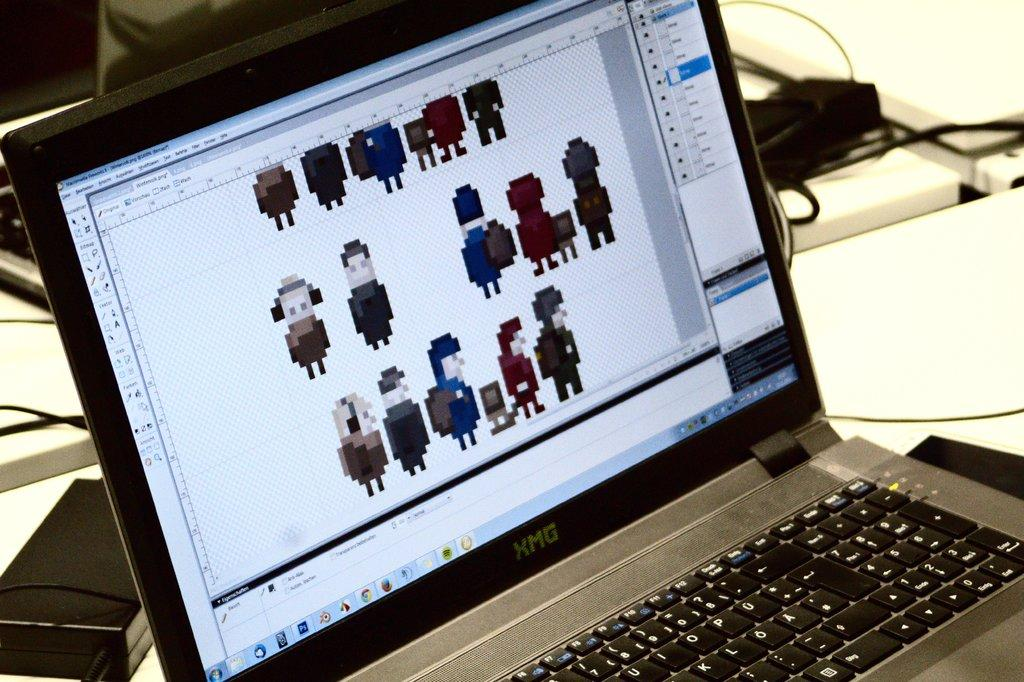<image>
Share a concise interpretation of the image provided. A small older laptop computer has an XMG logo. 